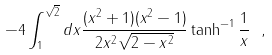<formula> <loc_0><loc_0><loc_500><loc_500>- 4 \int _ { 1 } ^ { \sqrt { 2 } } d x \frac { ( x ^ { 2 } + 1 ) ( x ^ { 2 } - 1 ) } { 2 x ^ { 2 } \sqrt { 2 - x ^ { 2 } } } \tanh ^ { - 1 } \frac { 1 } { x } \ ,</formula> 